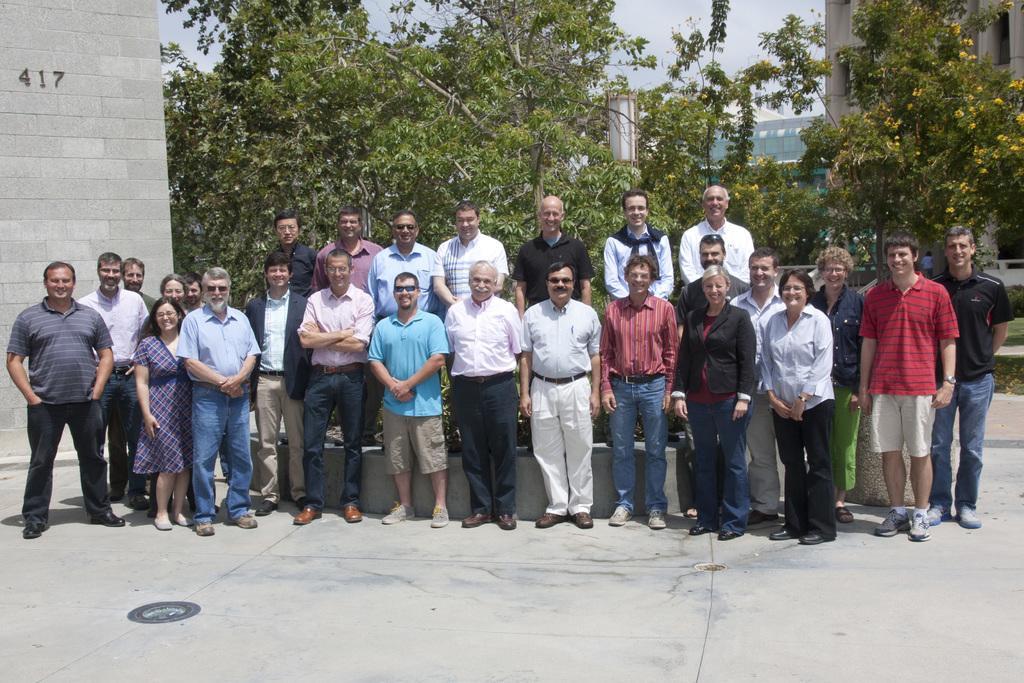Please provide a concise description of this image. In the image there are few people standing on the floor. Behind them there are few people standing on the small wall. On the left corner of the image there is a wall with number on it. In the background there are trees. There is a tree with yellow flowers. Behind the trees there are few buildings and also there is a sky. 